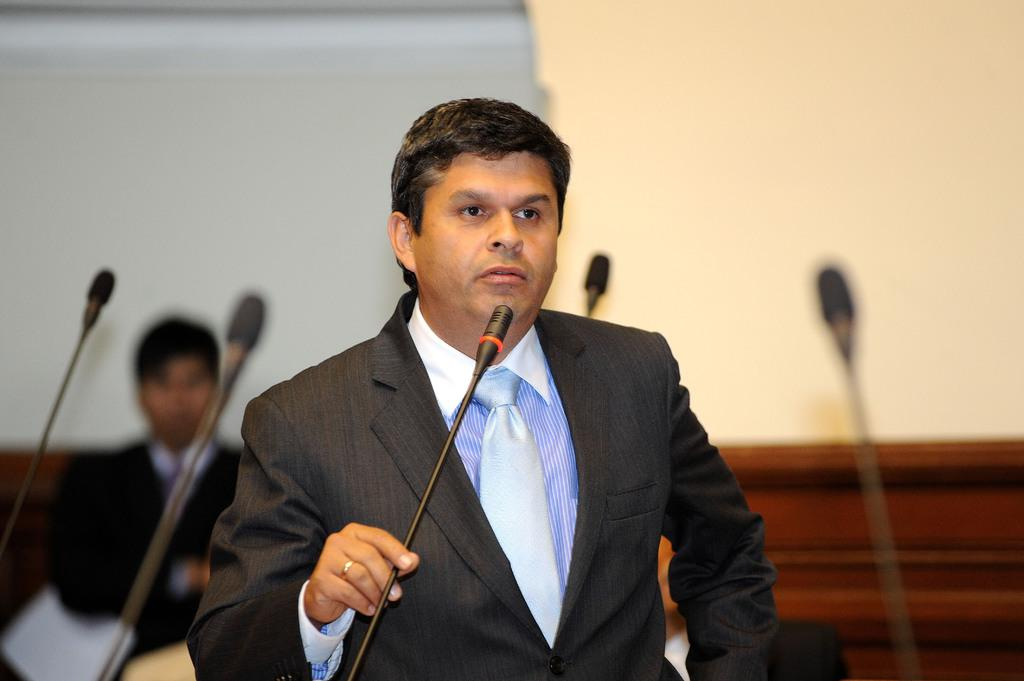What is the person in the image doing? The person in the image is standing and talking. What is the person holding in the image? The person is holding a microphone. Are there any other microphones visible in the image? Yes, there are microphones at the back of the image. What is the person at the back of the image holding? The person at the back is holding a paper. What type of chicken can be seen on the list held by the person at the back of the image? There is no chicken or list present in the image. How does the image reflect the winter season? The image does not reflect the winter season, as there are no specific details or elements that suggest a particular season. 